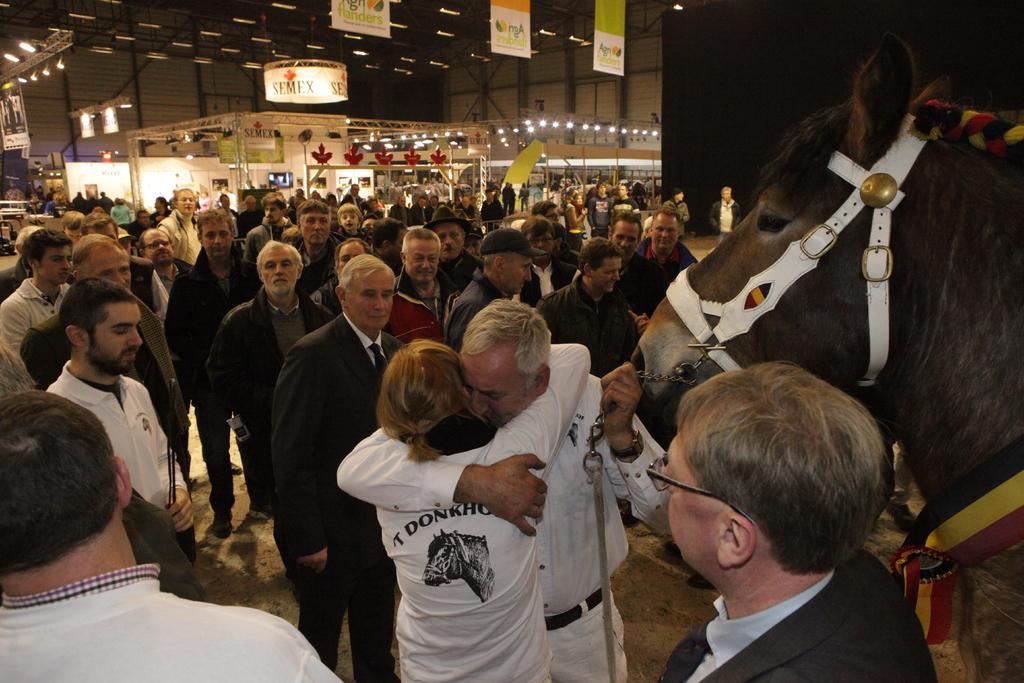How would you summarize this image in a sentence or two? As we can see in the image there are few people standing here and there and there is a banner and wall. 